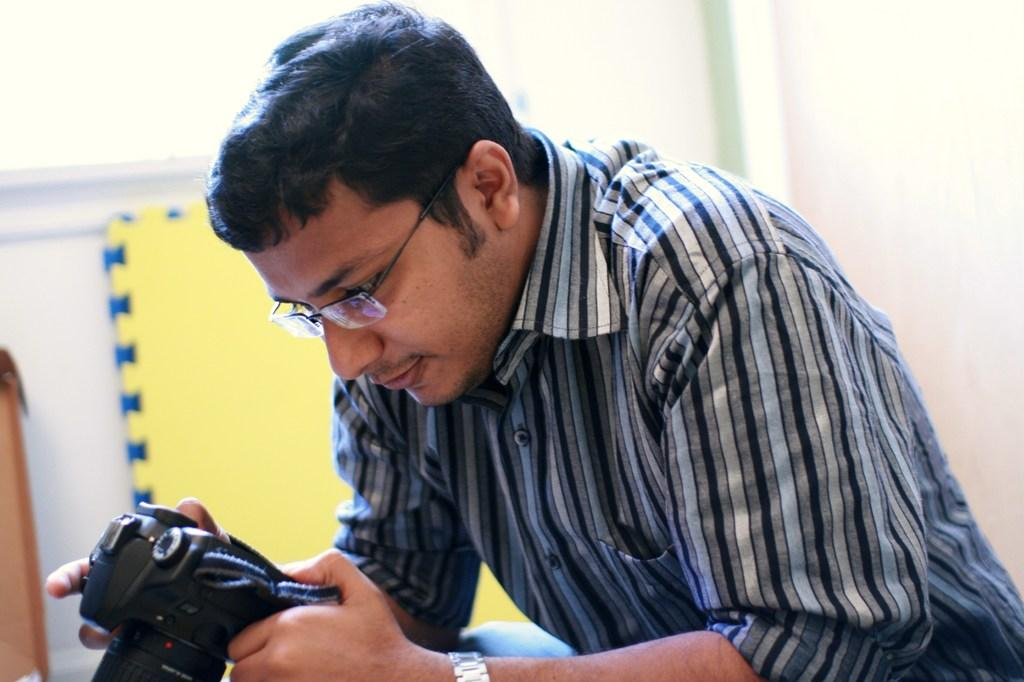What is the main subject of the image? The main subject of the image is a man. What is the man holding in the image? The man is holding a camera with his hand. Can you describe any accessories the man is wearing? The man is wearing spectacles. What can be seen in the background of the image? There is a wall in the background of the image. What type of knife is the man using to take a picture in the image? There is no knife present in the image; the man is using a camera to take a picture. What kind of toys can be seen on the wall in the image? There are no toys visible on the wall in the image; it only features a wall in the background. 